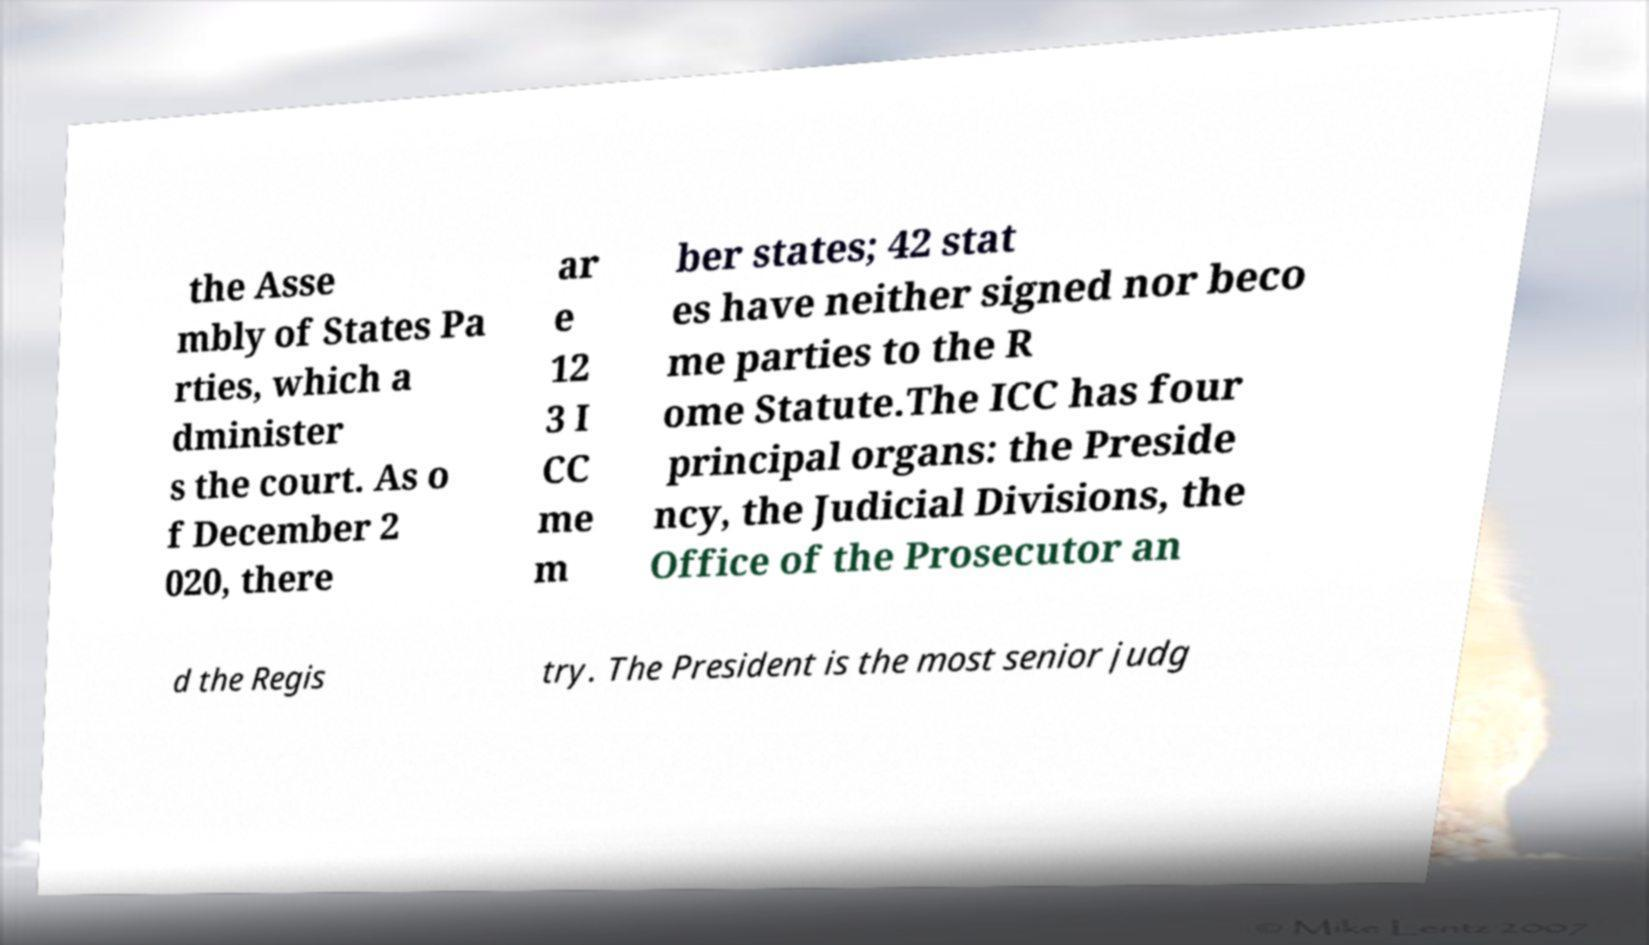Could you extract and type out the text from this image? the Asse mbly of States Pa rties, which a dminister s the court. As o f December 2 020, there ar e 12 3 I CC me m ber states; 42 stat es have neither signed nor beco me parties to the R ome Statute.The ICC has four principal organs: the Preside ncy, the Judicial Divisions, the Office of the Prosecutor an d the Regis try. The President is the most senior judg 